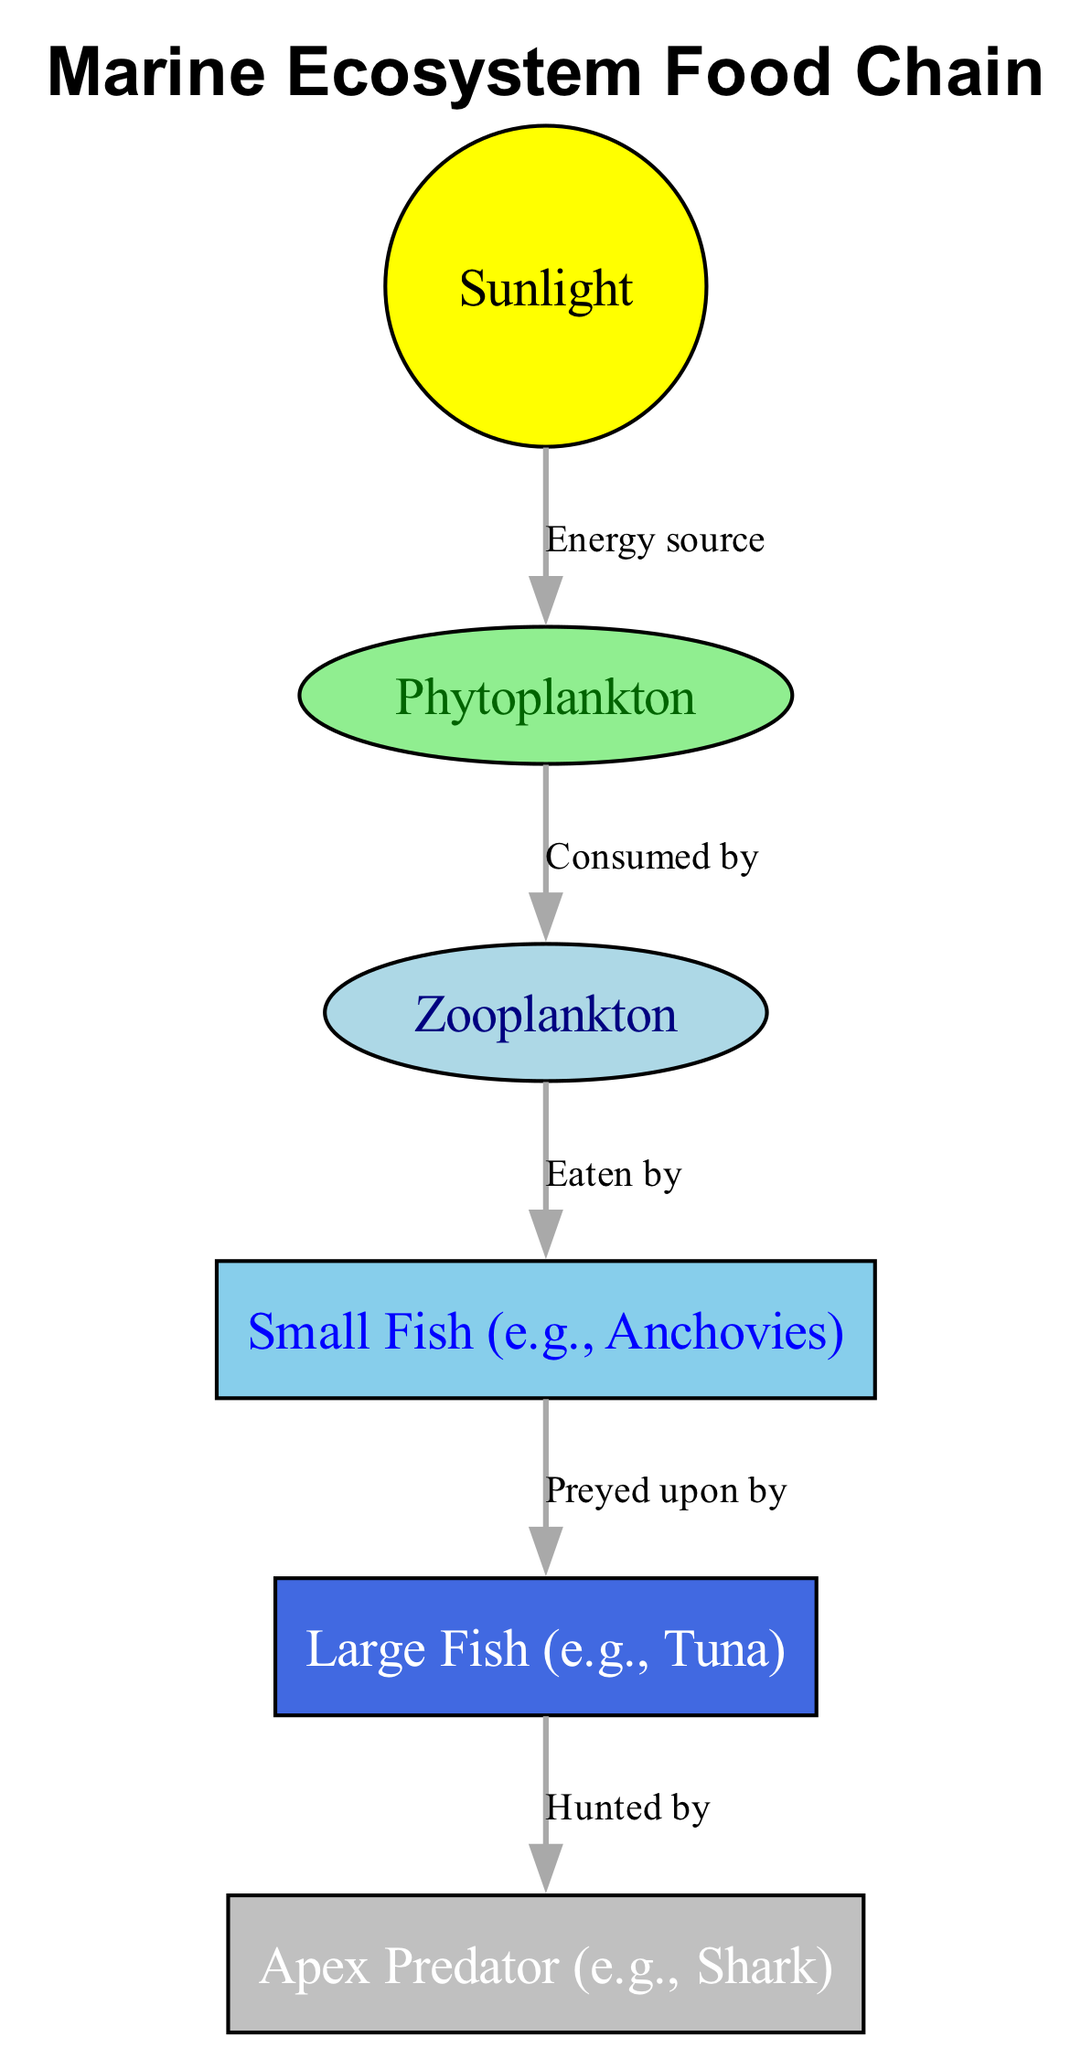What is the first element in the food chain? The diagram shows sunlight as the source of energy at the top. This is the first element in the food chain.
Answer: Sunlight How many nodes are present in the diagram? Upon counting all the distinct elements (sunlight, phytoplankton, zooplankton, small fish, large fish, shark), there are six nodes in total.
Answer: Six What do phytoplankton get energy from? The diagram indicates that phytoplankton receive their energy from sunlight, which is directly connected to phytoplankton by the "Energy source" label.
Answer: Sunlight Which element is consumed by zooplankton? The diagram clearly shows that zooplankton consume phytoplankton as indicated by the "Consumed by" relationship.
Answer: Phytoplankton What are large fish preyed upon by? The diagram shows a directed edge labeled "Preyed upon by" connecting large fish to the apex predator, which is a shark.
Answer: Shark How many edges are there in total? Counting all the directional relationships connecting the nodes (sunlight to phytoplankton, phytoplankton to zooplankton, zooplankton to small fish, small fish to large fish, and large fish to shark), there are five edges in total.
Answer: Five What is the last element in the food chain? The apex predator, represented by the shark, is the last element in the food chain, as it does not have a predator in this diagram.
Answer: Shark Which element is the primary consumer in this food chain? The primary consumer in this food chain is zooplankton, as it directly consumes phytoplankton.
Answer: Zooplankton What is the role of sunlight in this food chain? Sunlight serves as the energy source that initiates the food chain, fueling the first producer, phytoplankton.
Answer: Energy source 